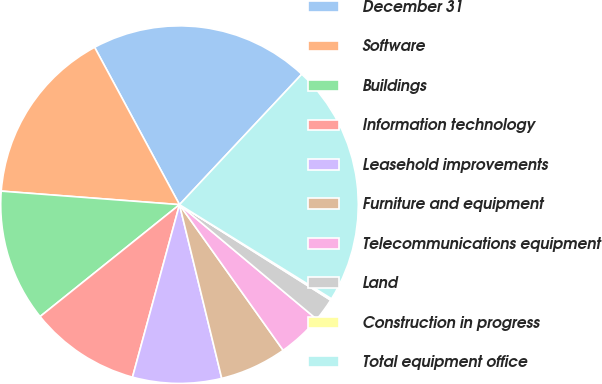Convert chart. <chart><loc_0><loc_0><loc_500><loc_500><pie_chart><fcel>December 31<fcel>Software<fcel>Buildings<fcel>Information technology<fcel>Leasehold improvements<fcel>Furniture and equipment<fcel>Telecommunications equipment<fcel>Land<fcel>Construction in progress<fcel>Total equipment office<nl><fcel>19.86%<fcel>15.92%<fcel>11.97%<fcel>10.0%<fcel>8.03%<fcel>6.05%<fcel>4.08%<fcel>2.11%<fcel>0.14%<fcel>21.84%<nl></chart> 